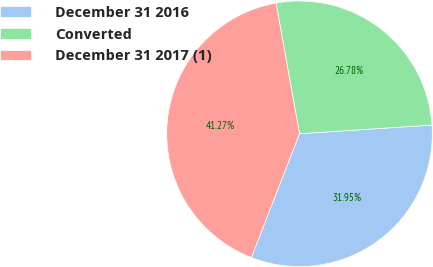Convert chart to OTSL. <chart><loc_0><loc_0><loc_500><loc_500><pie_chart><fcel>December 31 2016<fcel>Converted<fcel>December 31 2017 (1)<nl><fcel>31.95%<fcel>26.78%<fcel>41.27%<nl></chart> 